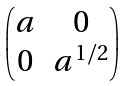Convert formula to latex. <formula><loc_0><loc_0><loc_500><loc_500>\begin{pmatrix} a & 0 \\ 0 & a ^ { 1 / 2 } \end{pmatrix}</formula> 